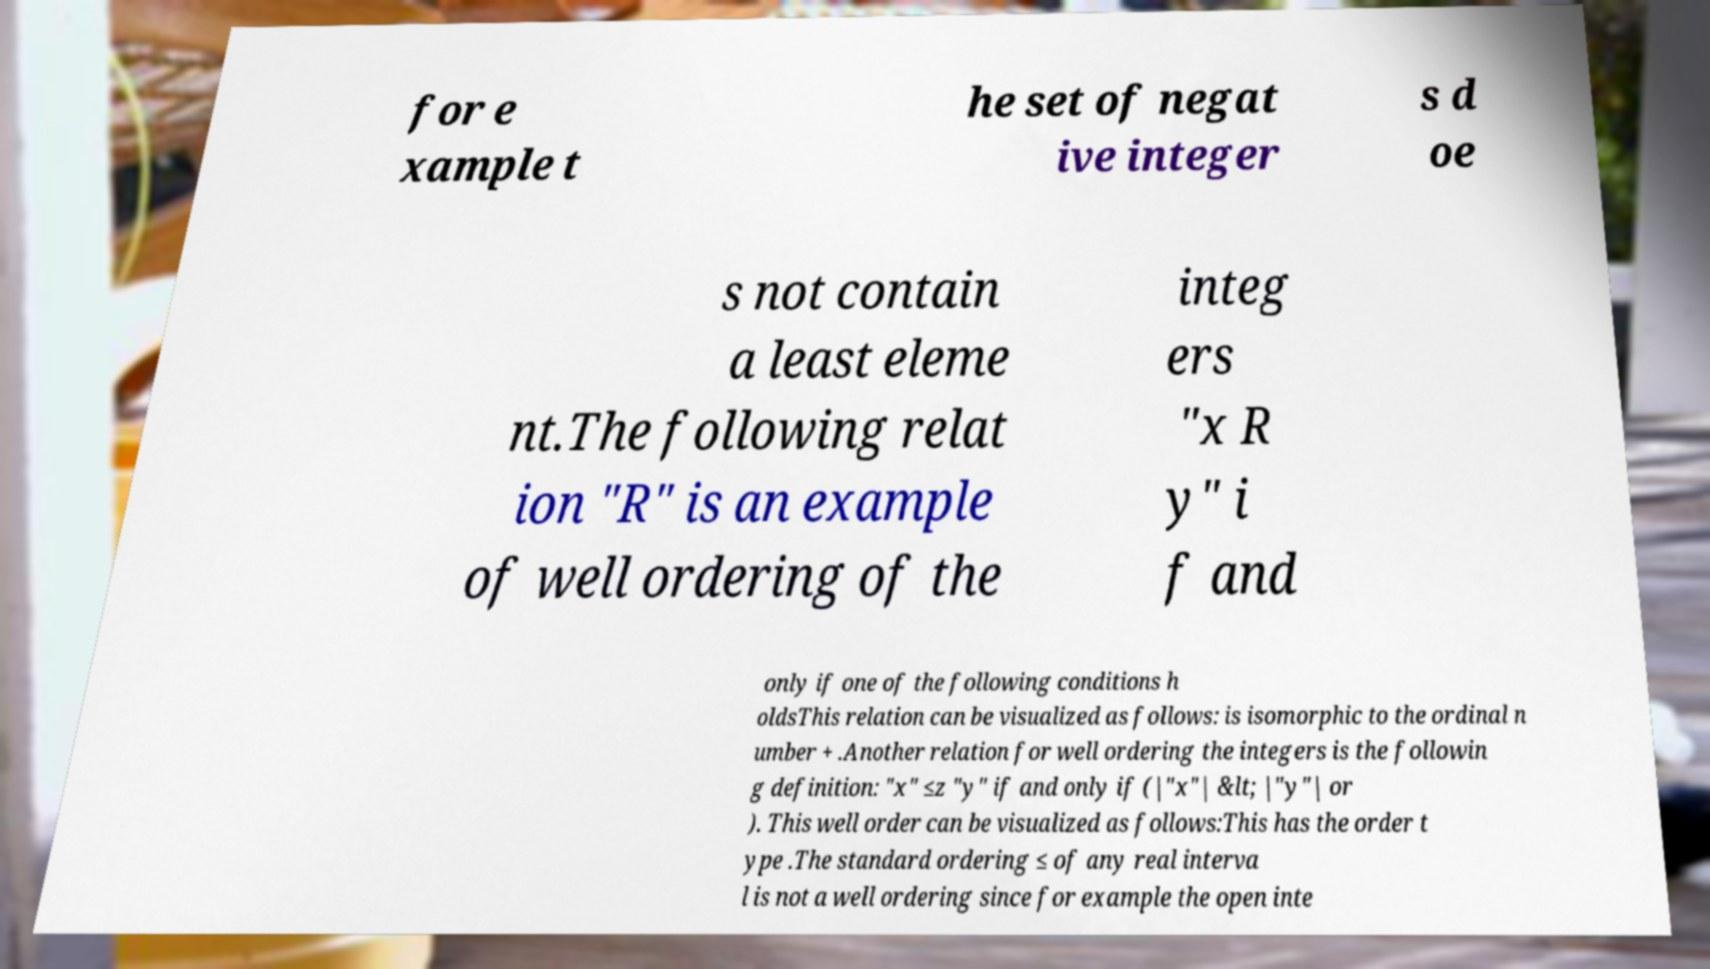What messages or text are displayed in this image? I need them in a readable, typed format. for e xample t he set of negat ive integer s d oe s not contain a least eleme nt.The following relat ion "R" is an example of well ordering of the integ ers "x R y" i f and only if one of the following conditions h oldsThis relation can be visualized as follows: is isomorphic to the ordinal n umber + .Another relation for well ordering the integers is the followin g definition: "x" ≤z "y" if and only if (|"x"| &lt; |"y"| or ). This well order can be visualized as follows:This has the order t ype .The standard ordering ≤ of any real interva l is not a well ordering since for example the open inte 